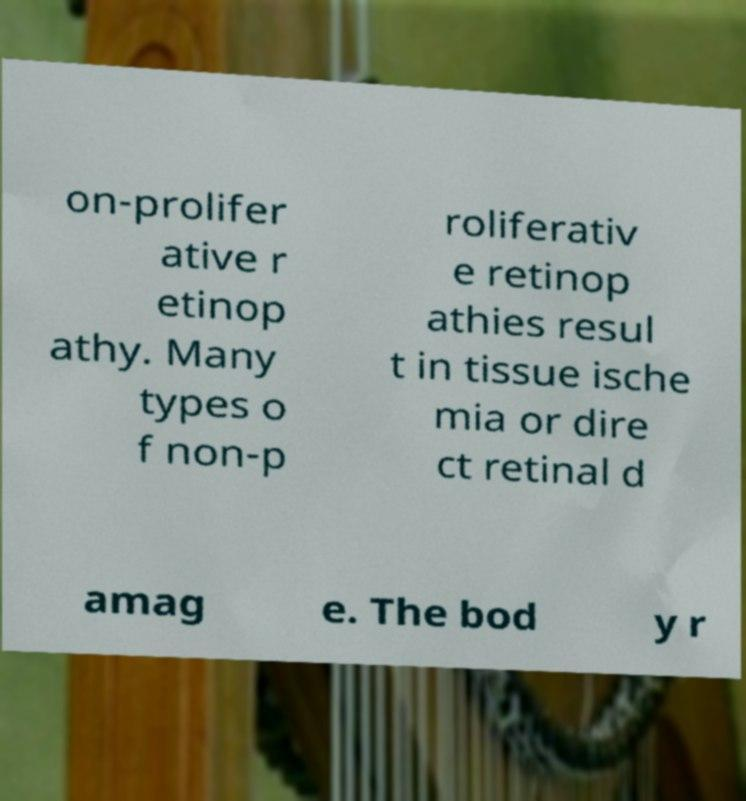For documentation purposes, I need the text within this image transcribed. Could you provide that? on-prolifer ative r etinop athy. Many types o f non-p roliferativ e retinop athies resul t in tissue ische mia or dire ct retinal d amag e. The bod y r 